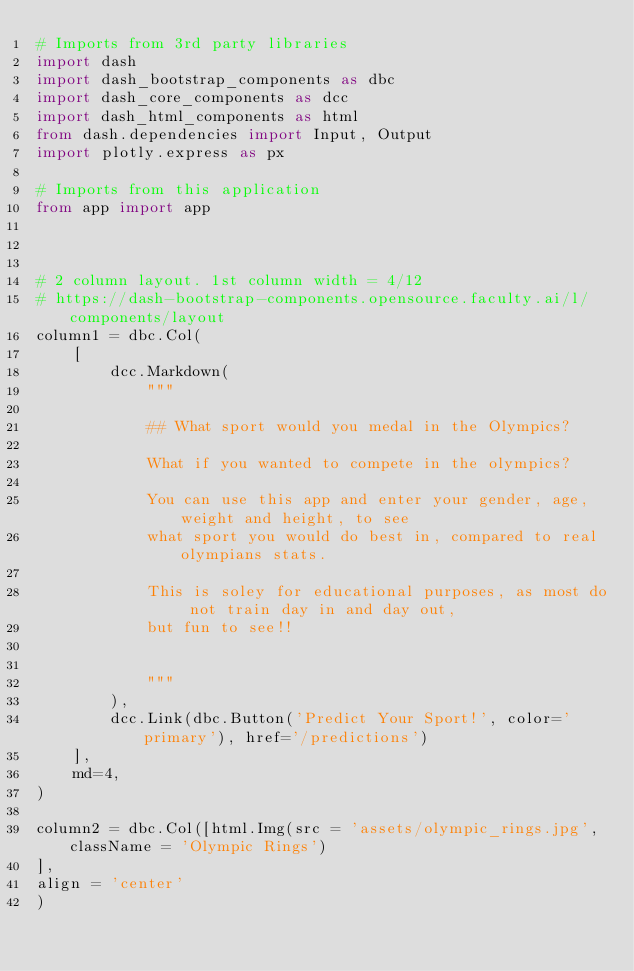Convert code to text. <code><loc_0><loc_0><loc_500><loc_500><_Python_># Imports from 3rd party libraries
import dash
import dash_bootstrap_components as dbc
import dash_core_components as dcc
import dash_html_components as html
from dash.dependencies import Input, Output
import plotly.express as px

# Imports from this application
from app import app



# 2 column layout. 1st column width = 4/12
# https://dash-bootstrap-components.opensource.faculty.ai/l/components/layout
column1 = dbc.Col(
    [
        dcc.Markdown(
            """
        
            ## What sport would you medal in the Olympics?

            What if you wanted to compete in the olympics?

            You can use this app and enter your gender, age, weight and height, to see 
            what sport you would do best in, compared to real olympians stats. 

            This is soley for educational purposes, as most do not train day in and day out,
            but fun to see!!
           
           
            """
        ),
        dcc.Link(dbc.Button('Predict Your Sport!', color='primary'), href='/predictions')
    ],
    md=4,
)

column2 = dbc.Col([html.Img(src = 'assets/olympic_rings.jpg', className = 'Olympic Rings')
],
align = 'center'
)
</code> 